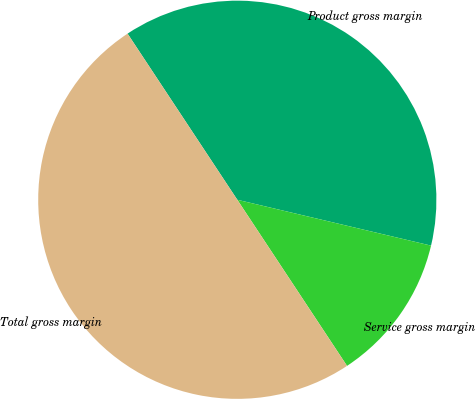<chart> <loc_0><loc_0><loc_500><loc_500><pie_chart><fcel>Product gross margin<fcel>Service gross margin<fcel>Total gross margin<nl><fcel>37.99%<fcel>12.01%<fcel>50.0%<nl></chart> 